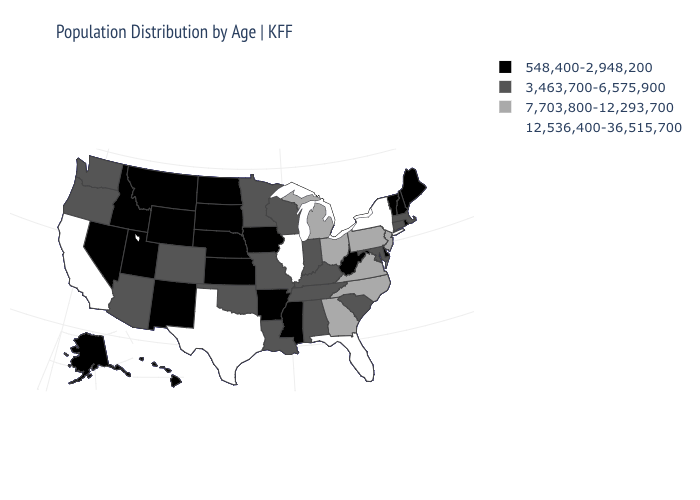Name the states that have a value in the range 548,400-2,948,200?
Short answer required. Alaska, Arkansas, Delaware, Hawaii, Idaho, Iowa, Kansas, Maine, Mississippi, Montana, Nebraska, Nevada, New Hampshire, New Mexico, North Dakota, Rhode Island, South Dakota, Utah, Vermont, West Virginia, Wyoming. Name the states that have a value in the range 12,536,400-36,515,700?
Concise answer only. California, Florida, Illinois, New York, Texas. Does South Dakota have the lowest value in the MidWest?
Give a very brief answer. Yes. What is the value of Michigan?
Give a very brief answer. 7,703,800-12,293,700. Name the states that have a value in the range 548,400-2,948,200?
Be succinct. Alaska, Arkansas, Delaware, Hawaii, Idaho, Iowa, Kansas, Maine, Mississippi, Montana, Nebraska, Nevada, New Hampshire, New Mexico, North Dakota, Rhode Island, South Dakota, Utah, Vermont, West Virginia, Wyoming. What is the lowest value in states that border South Carolina?
Write a very short answer. 7,703,800-12,293,700. What is the lowest value in the South?
Give a very brief answer. 548,400-2,948,200. Does Nebraska have the lowest value in the USA?
Keep it brief. Yes. Name the states that have a value in the range 7,703,800-12,293,700?
Be succinct. Georgia, Michigan, New Jersey, North Carolina, Ohio, Pennsylvania, Virginia. Among the states that border Montana , which have the lowest value?
Concise answer only. Idaho, North Dakota, South Dakota, Wyoming. What is the highest value in the West ?
Give a very brief answer. 12,536,400-36,515,700. What is the highest value in states that border Minnesota?
Be succinct. 3,463,700-6,575,900. Which states have the lowest value in the Northeast?
Quick response, please. Maine, New Hampshire, Rhode Island, Vermont. Among the states that border Kansas , does Missouri have the highest value?
Give a very brief answer. Yes. Does Mississippi have a lower value than Utah?
Concise answer only. No. 